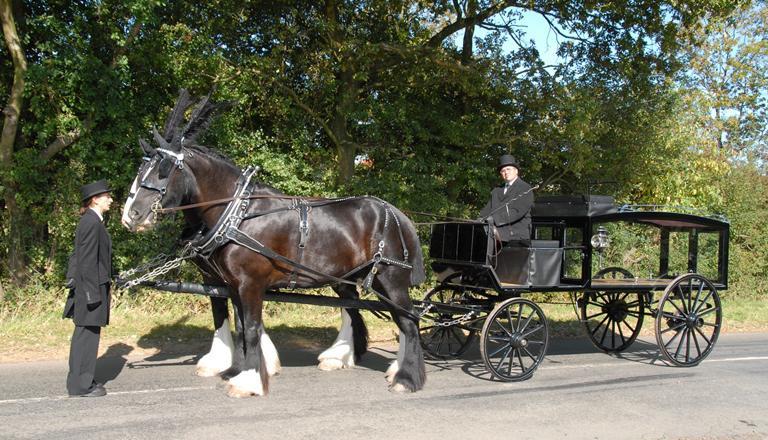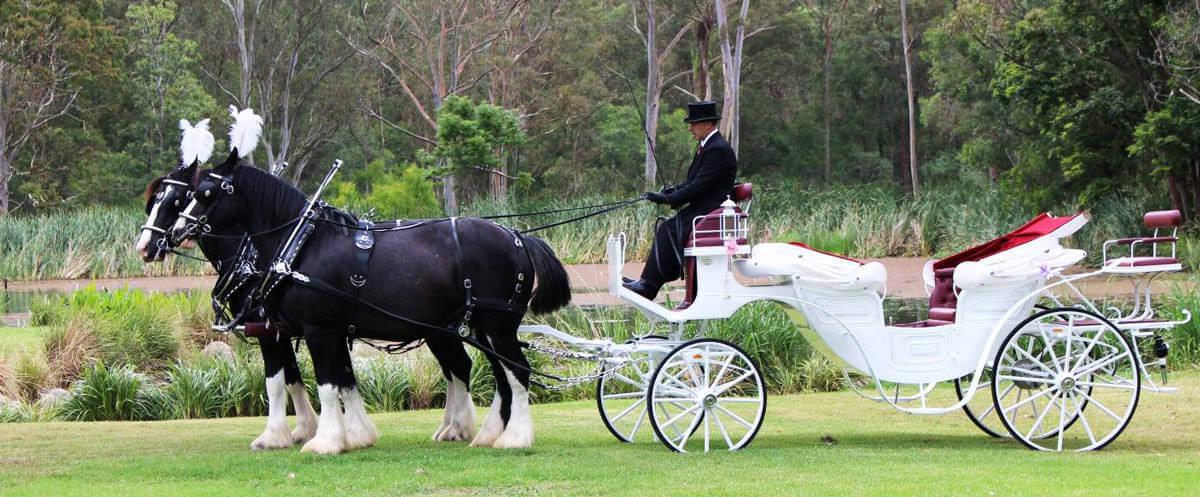The first image is the image on the left, the second image is the image on the right. Examine the images to the left and right. Is the description "The horse carriage are facing opposite directions from each other." accurate? Answer yes or no. No. The first image is the image on the left, the second image is the image on the right. For the images shown, is this caption "None of the wagons has more than a single person in the front seat." true? Answer yes or no. Yes. 